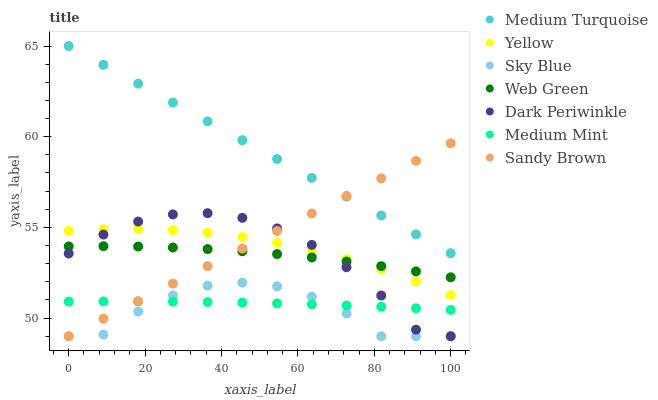Does Sky Blue have the minimum area under the curve?
Answer yes or no. Yes. Does Medium Turquoise have the maximum area under the curve?
Answer yes or no. Yes. Does Web Green have the minimum area under the curve?
Answer yes or no. No. Does Web Green have the maximum area under the curve?
Answer yes or no. No. Is Sandy Brown the smoothest?
Answer yes or no. Yes. Is Sky Blue the roughest?
Answer yes or no. Yes. Is Web Green the smoothest?
Answer yes or no. No. Is Web Green the roughest?
Answer yes or no. No. Does Sky Blue have the lowest value?
Answer yes or no. Yes. Does Web Green have the lowest value?
Answer yes or no. No. Does Medium Turquoise have the highest value?
Answer yes or no. Yes. Does Web Green have the highest value?
Answer yes or no. No. Is Web Green less than Medium Turquoise?
Answer yes or no. Yes. Is Medium Turquoise greater than Sky Blue?
Answer yes or no. Yes. Does Web Green intersect Dark Periwinkle?
Answer yes or no. Yes. Is Web Green less than Dark Periwinkle?
Answer yes or no. No. Is Web Green greater than Dark Periwinkle?
Answer yes or no. No. Does Web Green intersect Medium Turquoise?
Answer yes or no. No. 